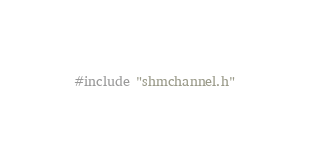<code> <loc_0><loc_0><loc_500><loc_500><_C_>#include "shmchannel.h"

</code> 